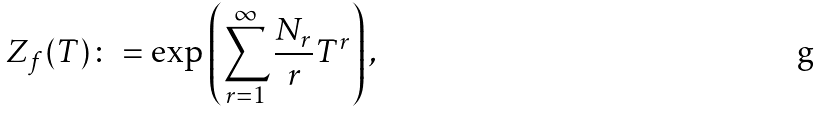Convert formula to latex. <formula><loc_0><loc_0><loc_500><loc_500>Z _ { f } ( T ) \colon = \exp \left ( \sum _ { r = 1 } ^ { \infty } \frac { N _ { r } } { r } T ^ { r } \right ) ,</formula> 